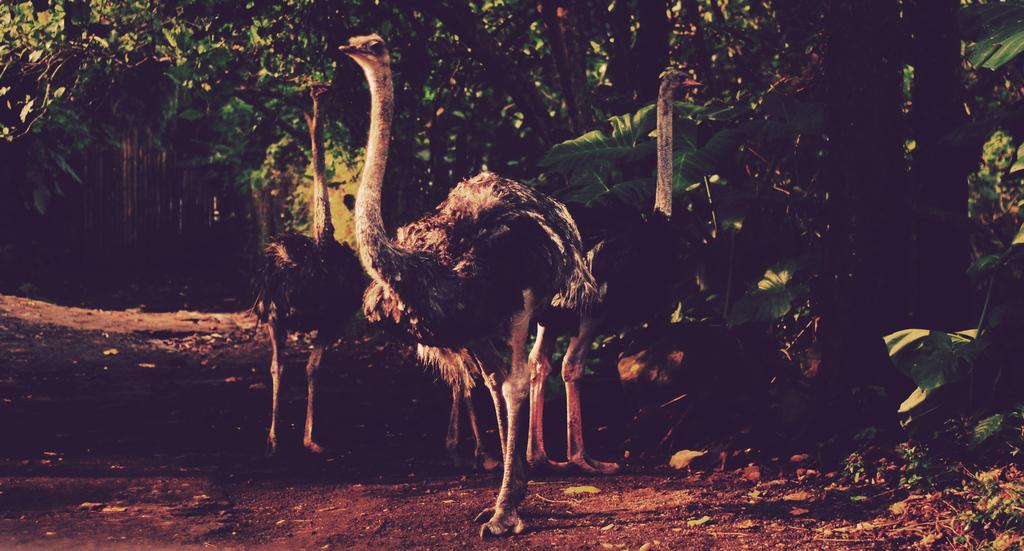What animals are in the center of the image? There are three ostriches in the center of the image. What can be seen in the background of the image? There is a background of trees in the image. What type of terrain is at the bottom of the image? There is sand at the bottom of the image. What type of plant material is present in the image? Dry leaves are present in the image. What type of vegetation is visible in the image? Grass is visible in the image. What degree does the cannon have in the image? There is no cannon present in the image, so it does not have a degree. 